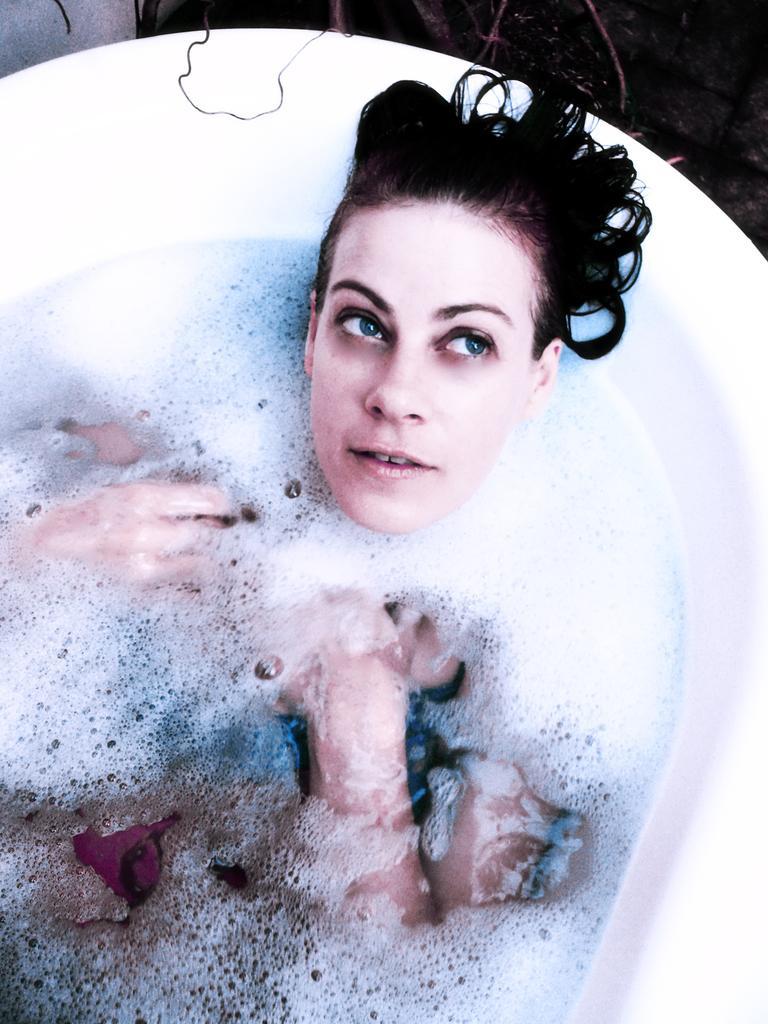Could you give a brief overview of what you see in this image? In this image I can see a white colored bathtub and in the bath tub I can see some water, foam and a person wearing blue and black colored dress. 